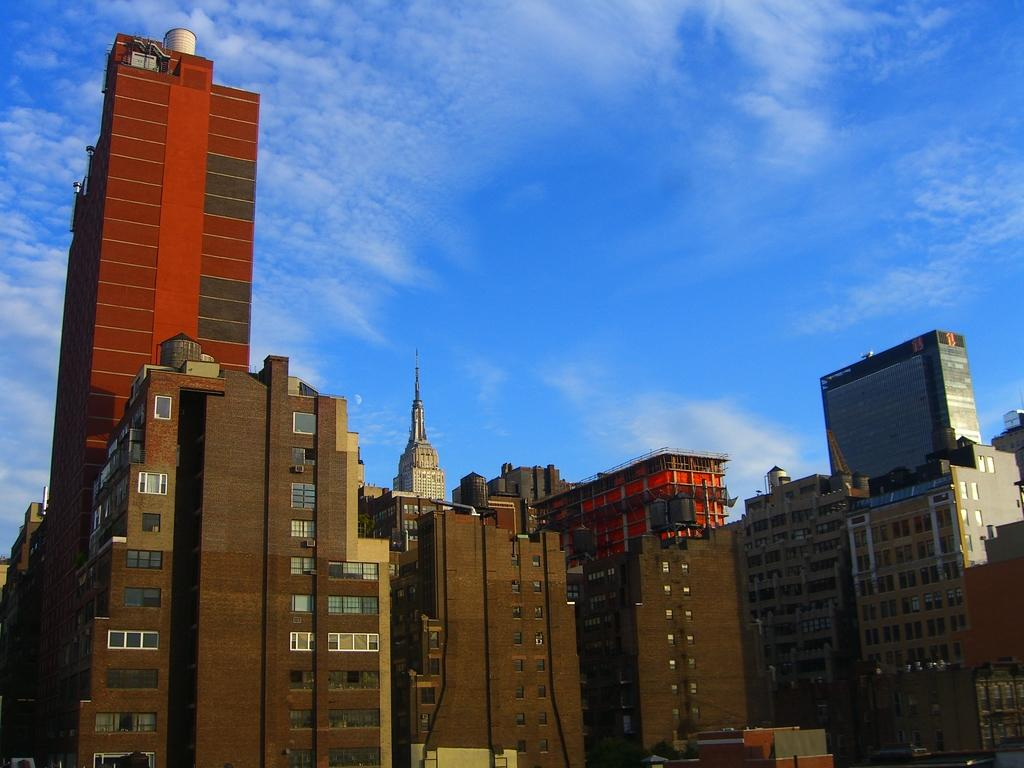Where was the image taken from? The image was taken from outside of a building. What can be seen in the image besides the building? There is a tower in the image. What type of windows are present on the building? There are glass windows in the image. What is visible at the top of the image? The sky is visible at the top of the image. What is the condition of the sky in the image? The sky is cloudy in the image. Can you tell me how many pickles are on the actor's head in the image? There are no pickles or actors present in the image; it features a building, tower, glass windows, and a cloudy sky. 